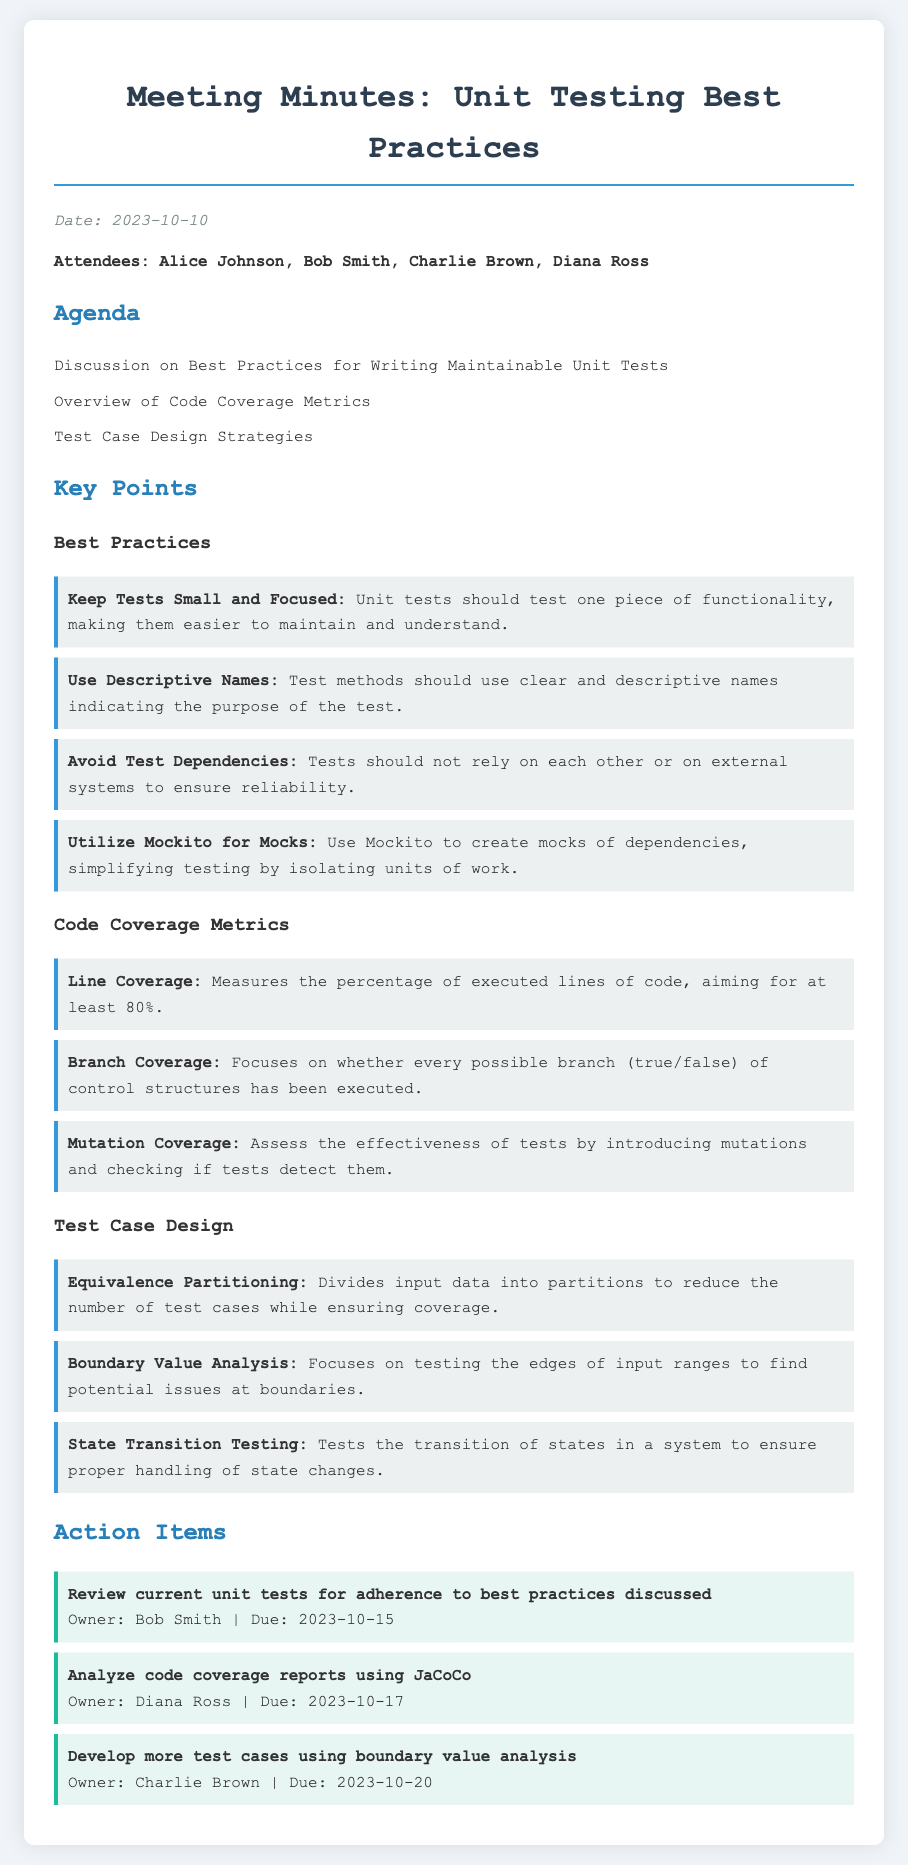What is the date of the meeting? The date of the meeting is stated in the document as 2023-10-10.
Answer: 2023-10-10 Who was the owner of the action item to review current unit tests? The owner of the action item regarding the review of unit tests is Bob Smith, mentioned under action items.
Answer: Bob Smith What is the purpose of using Mockito in unit tests? The document highlights that Mockito is used to create mocks of dependencies, aiding in isolation during testing.
Answer: Isolating units of work What percentage of line coverage is aimed for in code coverage metrics? The document specifies that line coverage aims for at least 80%.
Answer: 80% Which test case design strategy focuses on edges of input ranges? The document states that boundary value analysis focuses on testing the edges of input ranges.
Answer: Boundary Value Analysis What is one of the key points discussed regarding maintainability of unit tests? One of the key practices to ensure maintainability mentioned is to keep tests small and focused.
Answer: Keep Tests Small and Focused What action item is due on 2023-10-20? The document mentions that the action item to develop more test cases using boundary value analysis is due on this date.
Answer: Develop more test cases using boundary value analysis How many attendees were present at the meeting? The document lists a total of four attendees: Alice Johnson, Bob Smith, Charlie Brown, and Diana Ross.
Answer: Four 